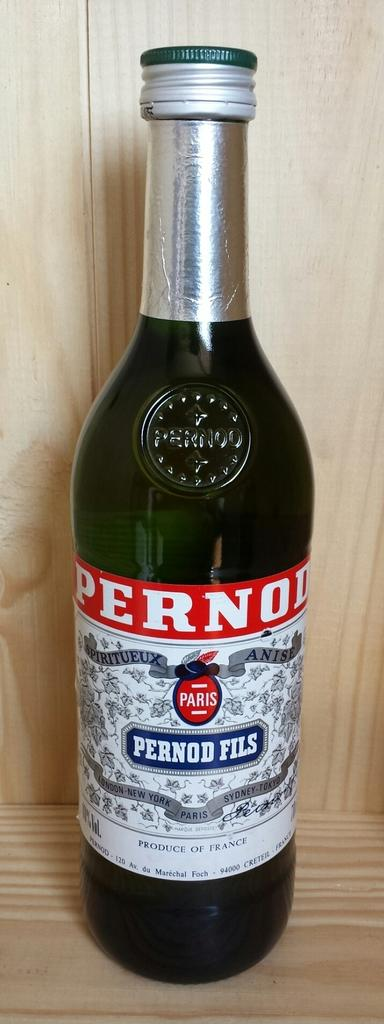<image>
Give a short and clear explanation of the subsequent image. A bottle of Pernod Fils is sitting on a wooden shelf. 